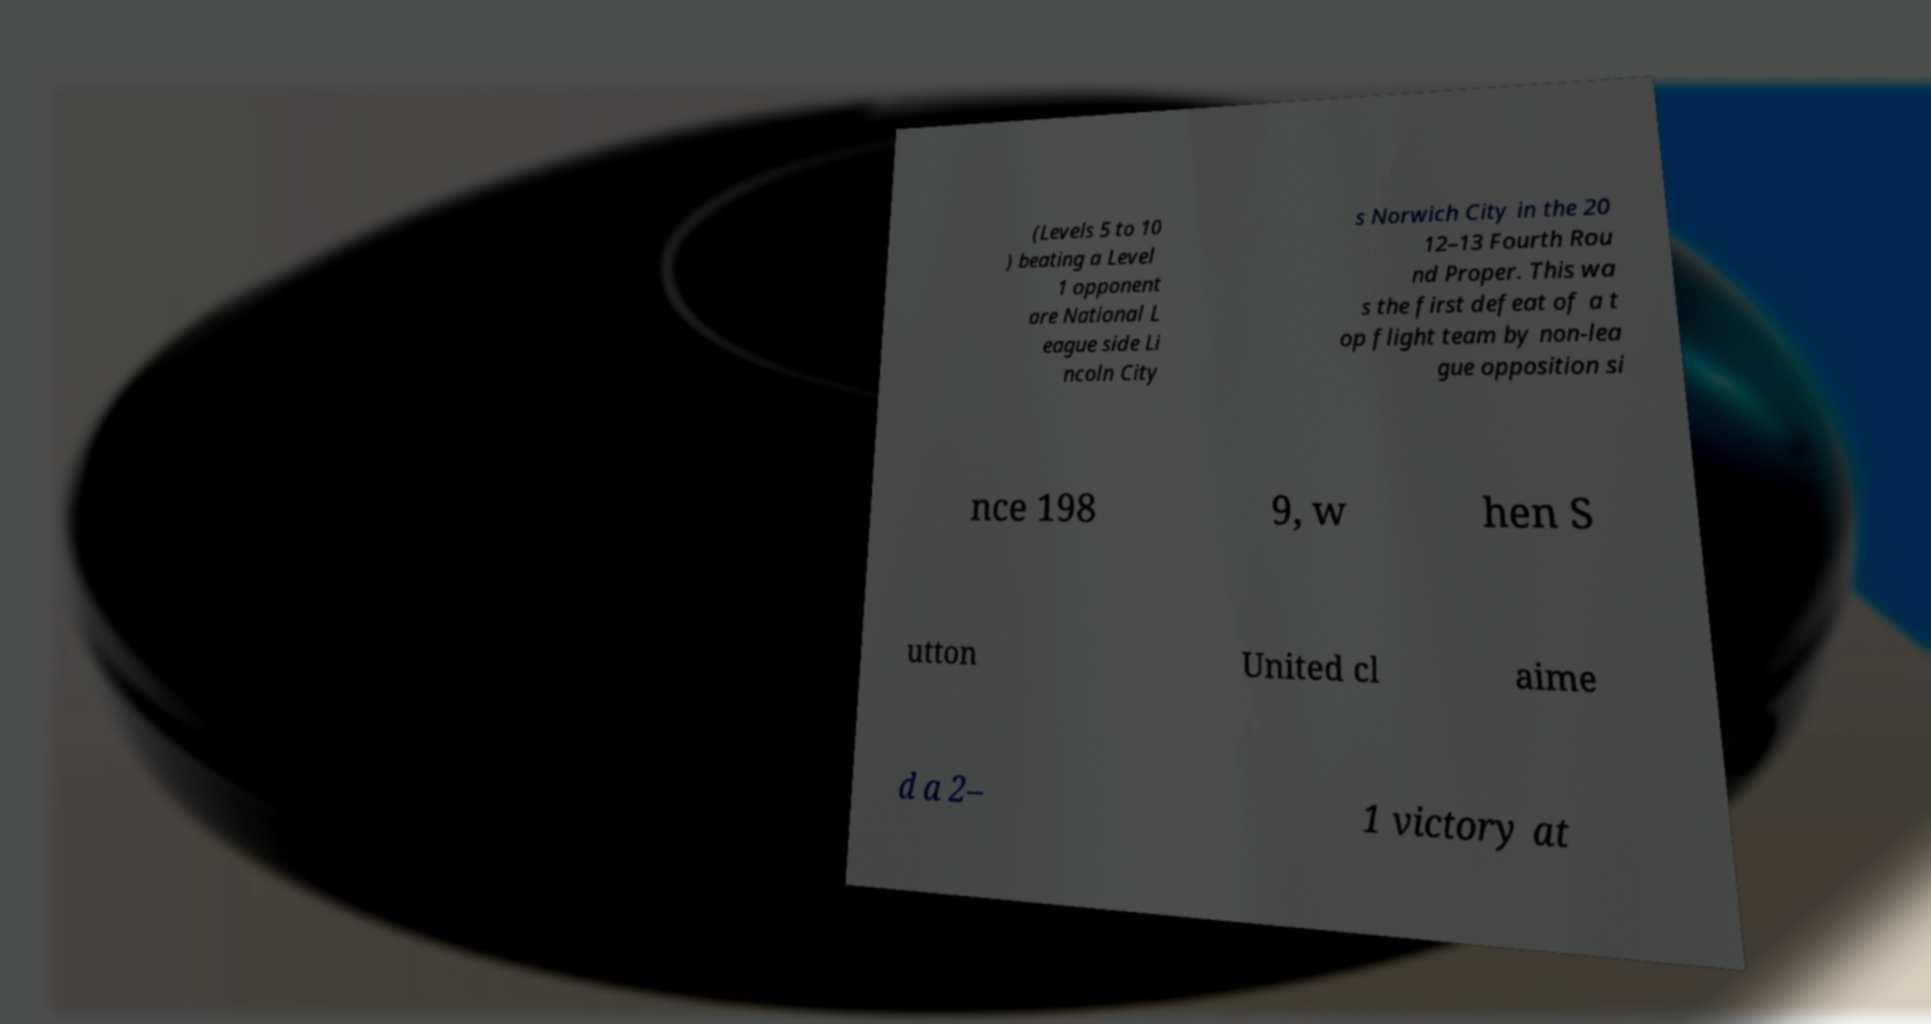Could you extract and type out the text from this image? (Levels 5 to 10 ) beating a Level 1 opponent are National L eague side Li ncoln City s Norwich City in the 20 12–13 Fourth Rou nd Proper. This wa s the first defeat of a t op flight team by non-lea gue opposition si nce 198 9, w hen S utton United cl aime d a 2– 1 victory at 